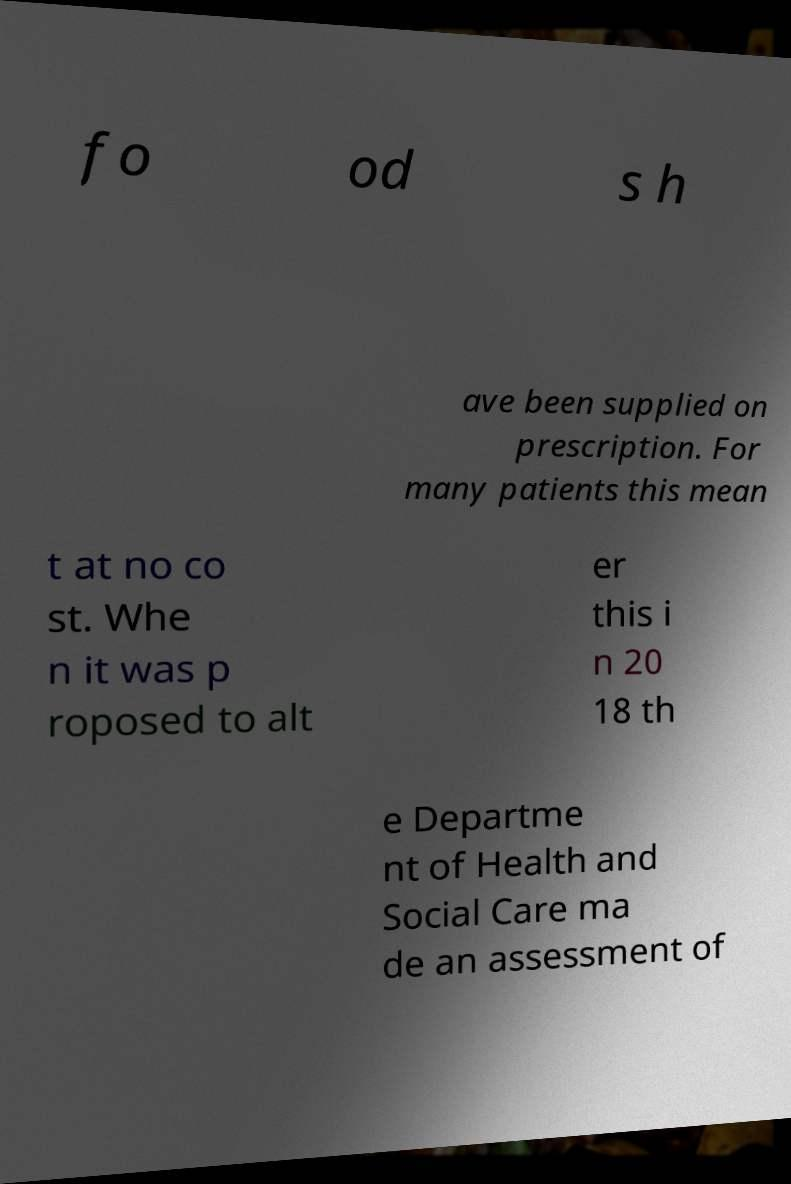There's text embedded in this image that I need extracted. Can you transcribe it verbatim? fo od s h ave been supplied on prescription. For many patients this mean t at no co st. Whe n it was p roposed to alt er this i n 20 18 th e Departme nt of Health and Social Care ma de an assessment of 